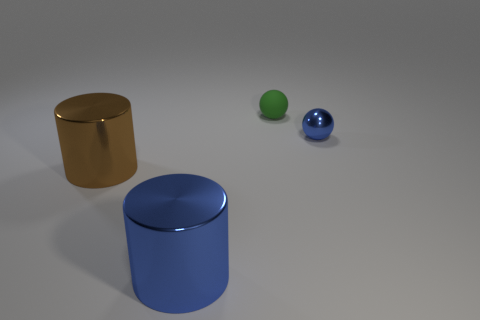Do the small metallic object to the right of the blue metallic cylinder and the shiny cylinder that is to the right of the brown object have the same color?
Offer a very short reply. Yes. What number of other objects are there of the same color as the small metal thing?
Offer a terse response. 1. There is a blue metal thing that is the same size as the brown shiny thing; what shape is it?
Give a very brief answer. Cylinder. There is a tiny thing to the right of the tiny green rubber ball; what is its color?
Provide a short and direct response. Blue. How many things are either large things to the right of the brown metallic cylinder or big cylinders right of the brown object?
Provide a short and direct response. 1. Do the shiny ball and the green rubber ball have the same size?
Offer a terse response. Yes. How many cylinders are big brown metal objects or small metal things?
Offer a very short reply. 1. What number of blue things are on the right side of the large blue metallic cylinder and in front of the large brown cylinder?
Give a very brief answer. 0. There is a brown shiny thing; does it have the same size as the metal cylinder to the right of the brown cylinder?
Provide a short and direct response. Yes. There is a cylinder to the left of the large cylinder on the right side of the brown cylinder; are there any metal spheres that are in front of it?
Your response must be concise. No. 